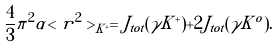Convert formula to latex. <formula><loc_0><loc_0><loc_500><loc_500>\frac { 4 } { 3 } \pi ^ { 2 } \alpha < r ^ { 2 } > _ { K ^ { + } } = J _ { t o t } ( \gamma K ^ { + } ) + 2 J _ { t o t } ( \gamma K ^ { o } ) .</formula> 